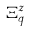Convert formula to latex. <formula><loc_0><loc_0><loc_500><loc_500>\Xi _ { q } ^ { z }</formula> 